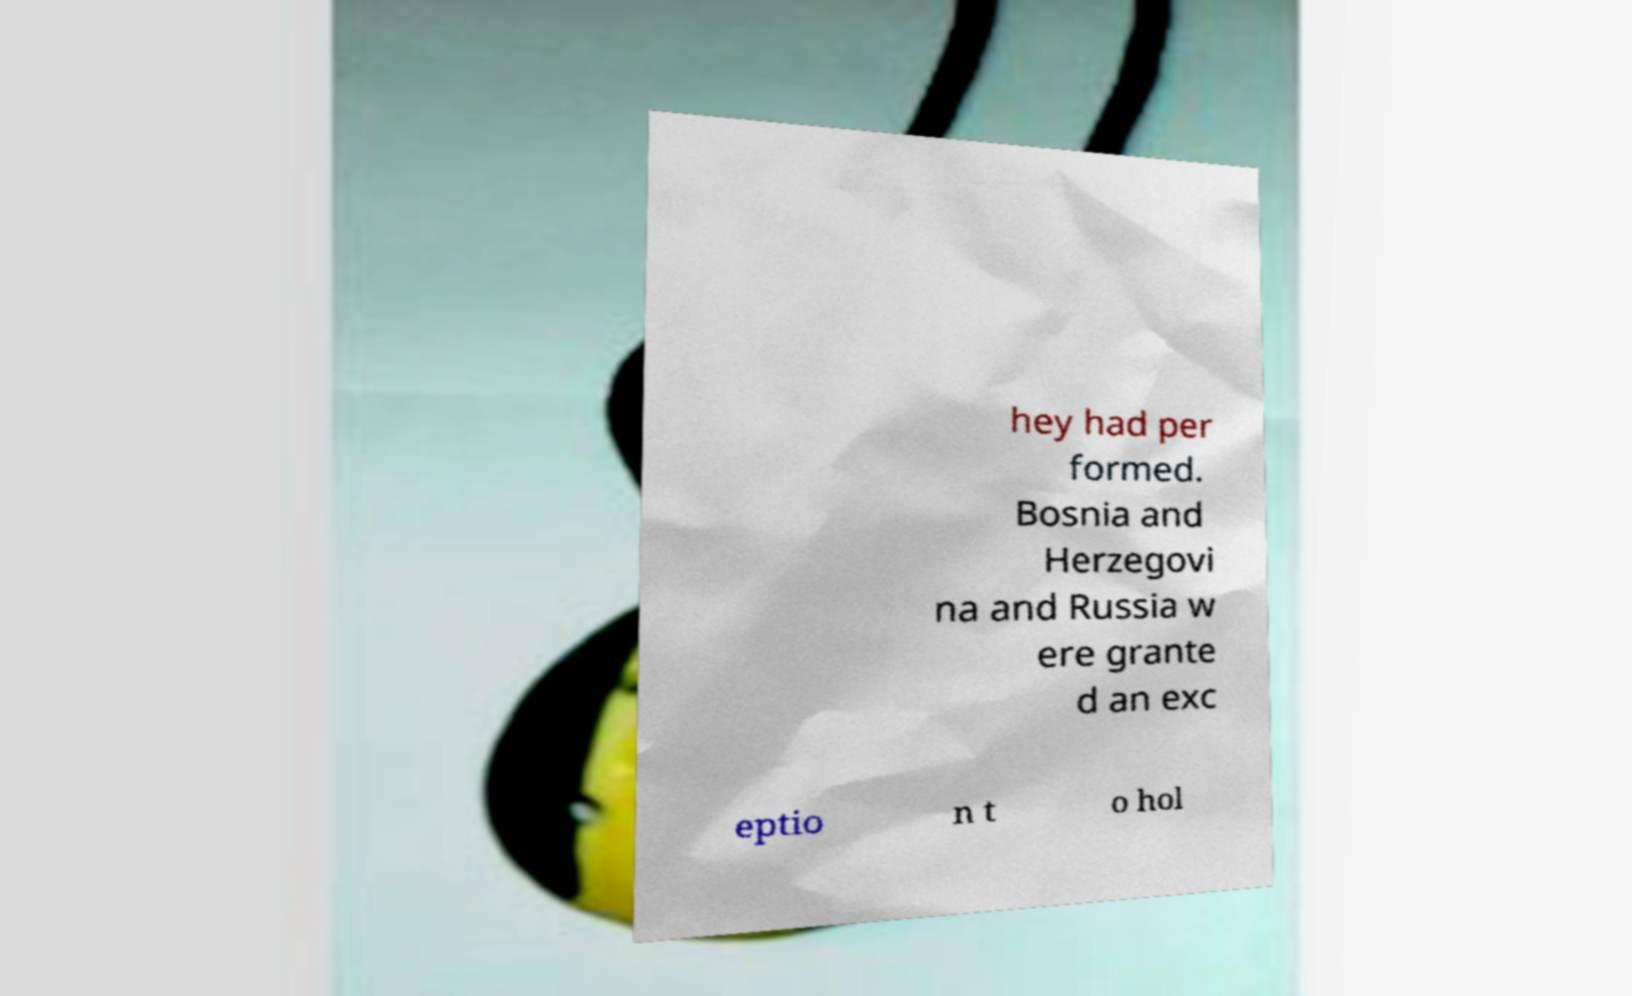There's text embedded in this image that I need extracted. Can you transcribe it verbatim? hey had per formed. Bosnia and Herzegovi na and Russia w ere grante d an exc eptio n t o hol 